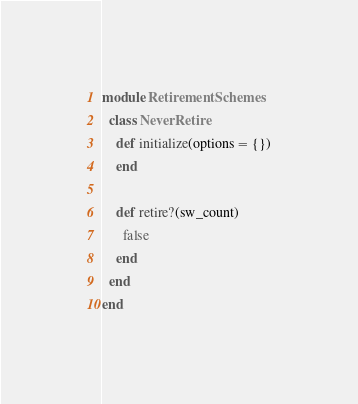Convert code to text. <code><loc_0><loc_0><loc_500><loc_500><_Ruby_>module RetirementSchemes
  class NeverRetire
    def initialize(options = {})
    end

    def retire?(sw_count)
      false
    end
  end
end
</code> 